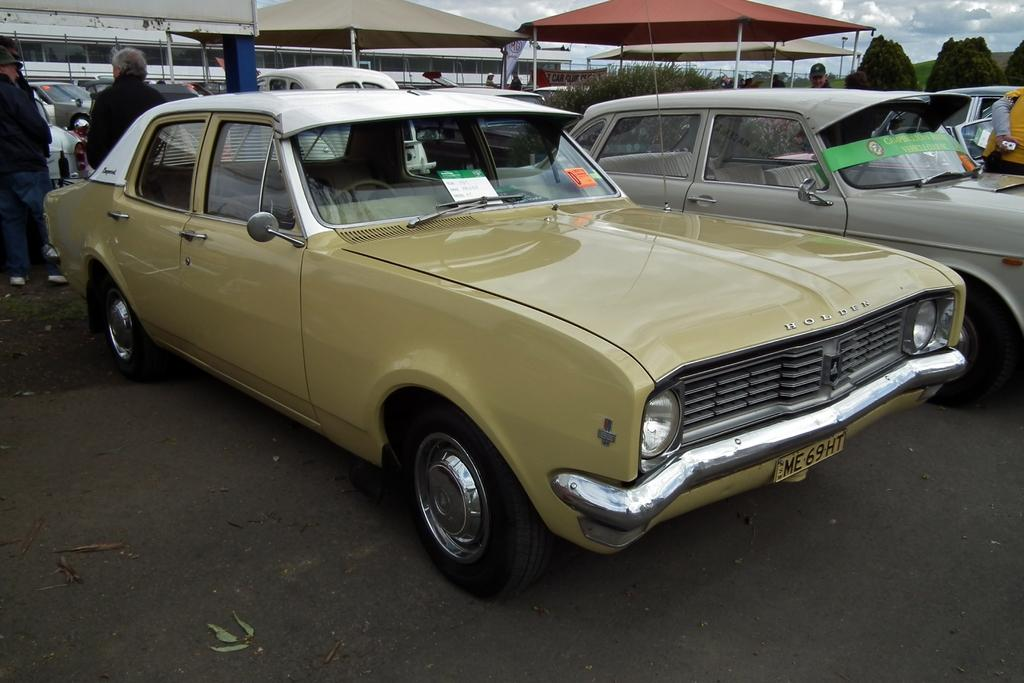What type of vehicles can be seen on the road in the image? There are cars on the road in the image. Who or what is present in the image besides the cars? There are people and plants visible in the image. What can be seen in the background of the image? There are tents, buildings, and the sky visible in the background of the image. What type of paper is being used to cover the houses in the image? There are no houses present in the image, and therefore no paper covering them. What color is the coat worn by the person in the image? There is no person wearing a coat in the image. 